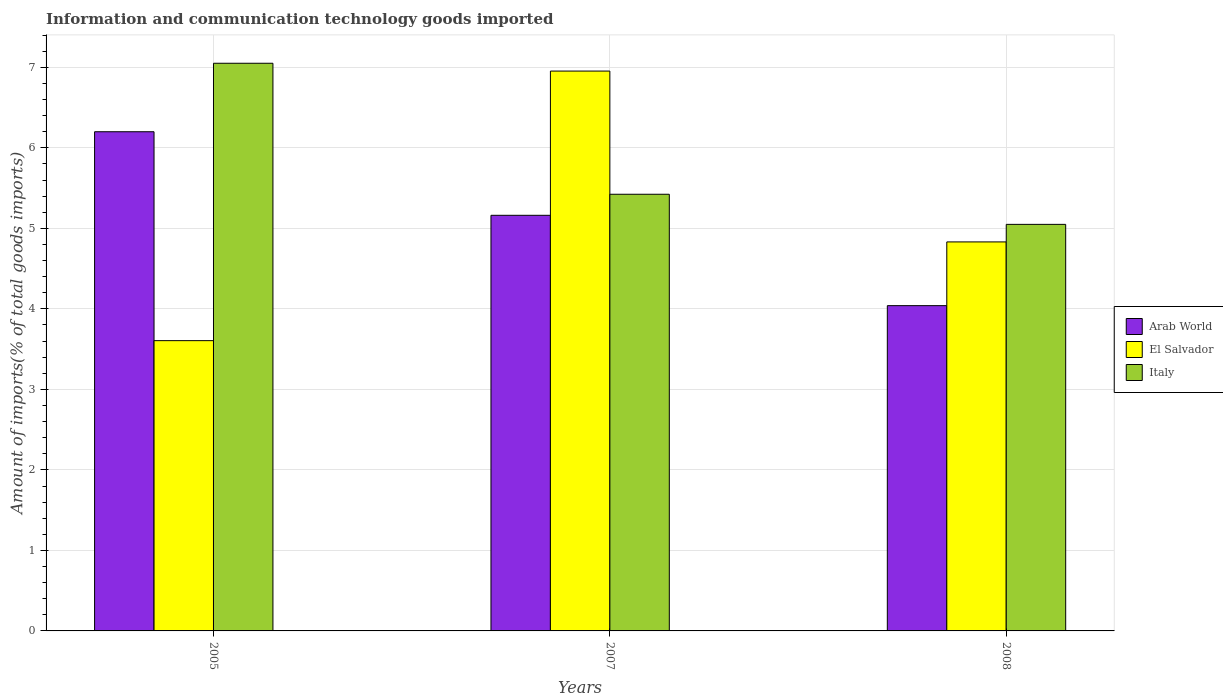What is the label of the 2nd group of bars from the left?
Give a very brief answer. 2007. What is the amount of goods imported in Italy in 2005?
Give a very brief answer. 7.05. Across all years, what is the maximum amount of goods imported in Italy?
Make the answer very short. 7.05. Across all years, what is the minimum amount of goods imported in Italy?
Your answer should be compact. 5.05. In which year was the amount of goods imported in Italy minimum?
Your response must be concise. 2008. What is the total amount of goods imported in Italy in the graph?
Provide a succinct answer. 17.52. What is the difference between the amount of goods imported in El Salvador in 2005 and that in 2008?
Provide a succinct answer. -1.23. What is the difference between the amount of goods imported in El Salvador in 2007 and the amount of goods imported in Arab World in 2005?
Provide a short and direct response. 0.75. What is the average amount of goods imported in Italy per year?
Make the answer very short. 5.84. In the year 2008, what is the difference between the amount of goods imported in Arab World and amount of goods imported in El Salvador?
Make the answer very short. -0.79. What is the ratio of the amount of goods imported in Italy in 2007 to that in 2008?
Your answer should be compact. 1.07. What is the difference between the highest and the second highest amount of goods imported in El Salvador?
Your answer should be compact. 2.12. What is the difference between the highest and the lowest amount of goods imported in El Salvador?
Your answer should be very brief. 3.35. In how many years, is the amount of goods imported in El Salvador greater than the average amount of goods imported in El Salvador taken over all years?
Keep it short and to the point. 1. Is the sum of the amount of goods imported in Arab World in 2005 and 2007 greater than the maximum amount of goods imported in El Salvador across all years?
Ensure brevity in your answer.  Yes. What does the 2nd bar from the left in 2005 represents?
Provide a short and direct response. El Salvador. What does the 2nd bar from the right in 2007 represents?
Give a very brief answer. El Salvador. What is the difference between two consecutive major ticks on the Y-axis?
Your response must be concise. 1. Does the graph contain grids?
Your answer should be very brief. Yes. How are the legend labels stacked?
Make the answer very short. Vertical. What is the title of the graph?
Provide a succinct answer. Information and communication technology goods imported. What is the label or title of the Y-axis?
Provide a succinct answer. Amount of imports(% of total goods imports). What is the Amount of imports(% of total goods imports) of Arab World in 2005?
Provide a succinct answer. 6.2. What is the Amount of imports(% of total goods imports) in El Salvador in 2005?
Ensure brevity in your answer.  3.61. What is the Amount of imports(% of total goods imports) in Italy in 2005?
Offer a very short reply. 7.05. What is the Amount of imports(% of total goods imports) of Arab World in 2007?
Make the answer very short. 5.16. What is the Amount of imports(% of total goods imports) of El Salvador in 2007?
Provide a short and direct response. 6.95. What is the Amount of imports(% of total goods imports) of Italy in 2007?
Give a very brief answer. 5.42. What is the Amount of imports(% of total goods imports) of Arab World in 2008?
Offer a terse response. 4.04. What is the Amount of imports(% of total goods imports) in El Salvador in 2008?
Provide a short and direct response. 4.83. What is the Amount of imports(% of total goods imports) in Italy in 2008?
Offer a very short reply. 5.05. Across all years, what is the maximum Amount of imports(% of total goods imports) of Arab World?
Your answer should be very brief. 6.2. Across all years, what is the maximum Amount of imports(% of total goods imports) in El Salvador?
Provide a short and direct response. 6.95. Across all years, what is the maximum Amount of imports(% of total goods imports) in Italy?
Keep it short and to the point. 7.05. Across all years, what is the minimum Amount of imports(% of total goods imports) of Arab World?
Your response must be concise. 4.04. Across all years, what is the minimum Amount of imports(% of total goods imports) in El Salvador?
Provide a short and direct response. 3.61. Across all years, what is the minimum Amount of imports(% of total goods imports) in Italy?
Provide a short and direct response. 5.05. What is the total Amount of imports(% of total goods imports) of Arab World in the graph?
Provide a short and direct response. 15.4. What is the total Amount of imports(% of total goods imports) in El Salvador in the graph?
Offer a terse response. 15.39. What is the total Amount of imports(% of total goods imports) in Italy in the graph?
Your answer should be compact. 17.52. What is the difference between the Amount of imports(% of total goods imports) of Arab World in 2005 and that in 2007?
Give a very brief answer. 1.04. What is the difference between the Amount of imports(% of total goods imports) of El Salvador in 2005 and that in 2007?
Give a very brief answer. -3.35. What is the difference between the Amount of imports(% of total goods imports) in Italy in 2005 and that in 2007?
Your response must be concise. 1.63. What is the difference between the Amount of imports(% of total goods imports) in Arab World in 2005 and that in 2008?
Give a very brief answer. 2.16. What is the difference between the Amount of imports(% of total goods imports) in El Salvador in 2005 and that in 2008?
Provide a short and direct response. -1.23. What is the difference between the Amount of imports(% of total goods imports) of Italy in 2005 and that in 2008?
Your answer should be compact. 2. What is the difference between the Amount of imports(% of total goods imports) of Arab World in 2007 and that in 2008?
Provide a short and direct response. 1.12. What is the difference between the Amount of imports(% of total goods imports) in El Salvador in 2007 and that in 2008?
Your answer should be compact. 2.12. What is the difference between the Amount of imports(% of total goods imports) in Italy in 2007 and that in 2008?
Offer a very short reply. 0.37. What is the difference between the Amount of imports(% of total goods imports) in Arab World in 2005 and the Amount of imports(% of total goods imports) in El Salvador in 2007?
Keep it short and to the point. -0.75. What is the difference between the Amount of imports(% of total goods imports) in Arab World in 2005 and the Amount of imports(% of total goods imports) in Italy in 2007?
Make the answer very short. 0.78. What is the difference between the Amount of imports(% of total goods imports) in El Salvador in 2005 and the Amount of imports(% of total goods imports) in Italy in 2007?
Offer a terse response. -1.82. What is the difference between the Amount of imports(% of total goods imports) of Arab World in 2005 and the Amount of imports(% of total goods imports) of El Salvador in 2008?
Make the answer very short. 1.37. What is the difference between the Amount of imports(% of total goods imports) in Arab World in 2005 and the Amount of imports(% of total goods imports) in Italy in 2008?
Your answer should be compact. 1.15. What is the difference between the Amount of imports(% of total goods imports) in El Salvador in 2005 and the Amount of imports(% of total goods imports) in Italy in 2008?
Your response must be concise. -1.44. What is the difference between the Amount of imports(% of total goods imports) of Arab World in 2007 and the Amount of imports(% of total goods imports) of El Salvador in 2008?
Your answer should be compact. 0.33. What is the difference between the Amount of imports(% of total goods imports) in Arab World in 2007 and the Amount of imports(% of total goods imports) in Italy in 2008?
Your response must be concise. 0.11. What is the difference between the Amount of imports(% of total goods imports) in El Salvador in 2007 and the Amount of imports(% of total goods imports) in Italy in 2008?
Your response must be concise. 1.9. What is the average Amount of imports(% of total goods imports) in Arab World per year?
Provide a short and direct response. 5.13. What is the average Amount of imports(% of total goods imports) in El Salvador per year?
Ensure brevity in your answer.  5.13. What is the average Amount of imports(% of total goods imports) of Italy per year?
Give a very brief answer. 5.84. In the year 2005, what is the difference between the Amount of imports(% of total goods imports) of Arab World and Amount of imports(% of total goods imports) of El Salvador?
Offer a very short reply. 2.59. In the year 2005, what is the difference between the Amount of imports(% of total goods imports) of Arab World and Amount of imports(% of total goods imports) of Italy?
Provide a short and direct response. -0.85. In the year 2005, what is the difference between the Amount of imports(% of total goods imports) in El Salvador and Amount of imports(% of total goods imports) in Italy?
Provide a short and direct response. -3.45. In the year 2007, what is the difference between the Amount of imports(% of total goods imports) in Arab World and Amount of imports(% of total goods imports) in El Salvador?
Your answer should be very brief. -1.79. In the year 2007, what is the difference between the Amount of imports(% of total goods imports) in Arab World and Amount of imports(% of total goods imports) in Italy?
Your answer should be very brief. -0.26. In the year 2007, what is the difference between the Amount of imports(% of total goods imports) in El Salvador and Amount of imports(% of total goods imports) in Italy?
Offer a very short reply. 1.53. In the year 2008, what is the difference between the Amount of imports(% of total goods imports) in Arab World and Amount of imports(% of total goods imports) in El Salvador?
Offer a very short reply. -0.79. In the year 2008, what is the difference between the Amount of imports(% of total goods imports) in Arab World and Amount of imports(% of total goods imports) in Italy?
Offer a very short reply. -1.01. In the year 2008, what is the difference between the Amount of imports(% of total goods imports) in El Salvador and Amount of imports(% of total goods imports) in Italy?
Your response must be concise. -0.22. What is the ratio of the Amount of imports(% of total goods imports) of Arab World in 2005 to that in 2007?
Your answer should be very brief. 1.2. What is the ratio of the Amount of imports(% of total goods imports) of El Salvador in 2005 to that in 2007?
Give a very brief answer. 0.52. What is the ratio of the Amount of imports(% of total goods imports) of Arab World in 2005 to that in 2008?
Keep it short and to the point. 1.53. What is the ratio of the Amount of imports(% of total goods imports) in El Salvador in 2005 to that in 2008?
Offer a very short reply. 0.75. What is the ratio of the Amount of imports(% of total goods imports) in Italy in 2005 to that in 2008?
Make the answer very short. 1.4. What is the ratio of the Amount of imports(% of total goods imports) of Arab World in 2007 to that in 2008?
Keep it short and to the point. 1.28. What is the ratio of the Amount of imports(% of total goods imports) in El Salvador in 2007 to that in 2008?
Make the answer very short. 1.44. What is the ratio of the Amount of imports(% of total goods imports) of Italy in 2007 to that in 2008?
Offer a terse response. 1.07. What is the difference between the highest and the second highest Amount of imports(% of total goods imports) in Arab World?
Provide a succinct answer. 1.04. What is the difference between the highest and the second highest Amount of imports(% of total goods imports) of El Salvador?
Your answer should be very brief. 2.12. What is the difference between the highest and the second highest Amount of imports(% of total goods imports) in Italy?
Keep it short and to the point. 1.63. What is the difference between the highest and the lowest Amount of imports(% of total goods imports) of Arab World?
Ensure brevity in your answer.  2.16. What is the difference between the highest and the lowest Amount of imports(% of total goods imports) of El Salvador?
Provide a short and direct response. 3.35. What is the difference between the highest and the lowest Amount of imports(% of total goods imports) in Italy?
Keep it short and to the point. 2. 